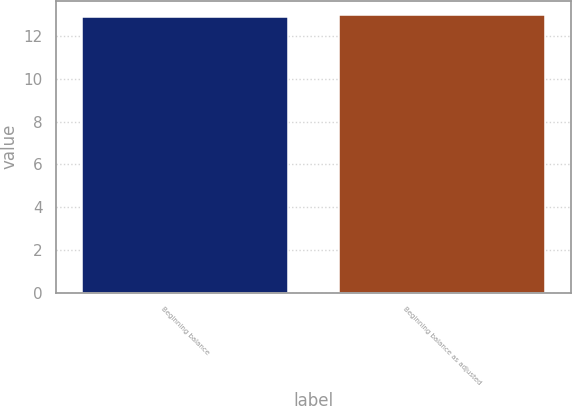Convert chart to OTSL. <chart><loc_0><loc_0><loc_500><loc_500><bar_chart><fcel>Beginning balance<fcel>Beginning balance as adjusted<nl><fcel>12.9<fcel>13<nl></chart> 